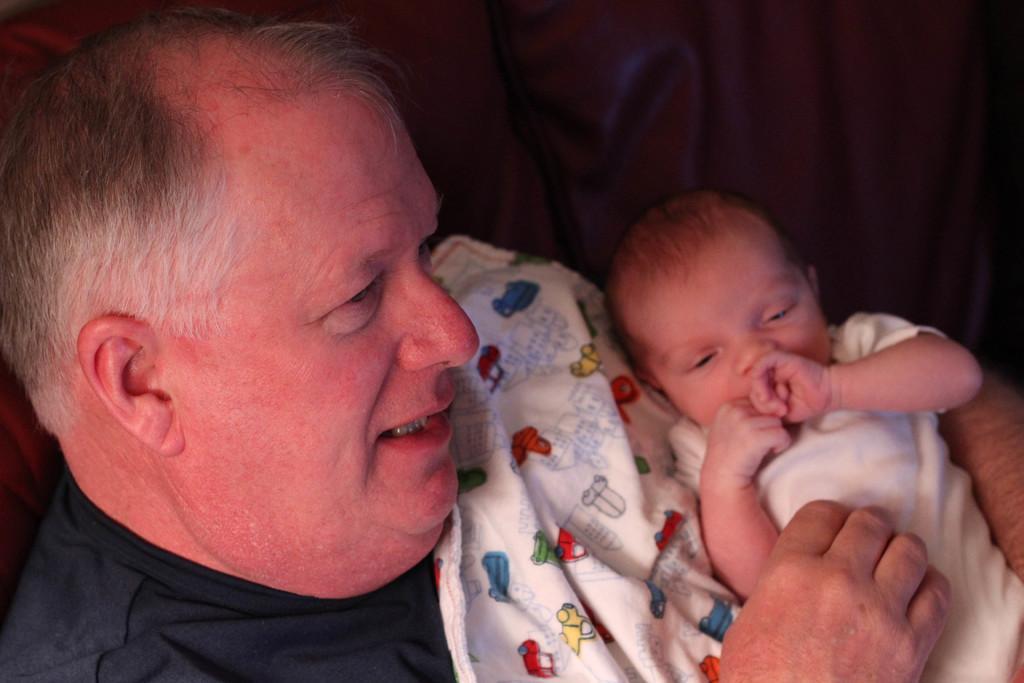Describe this image in one or two sentences. Here in this picture we can see an old man holding a baby in his hands with a blanket under him over there. 